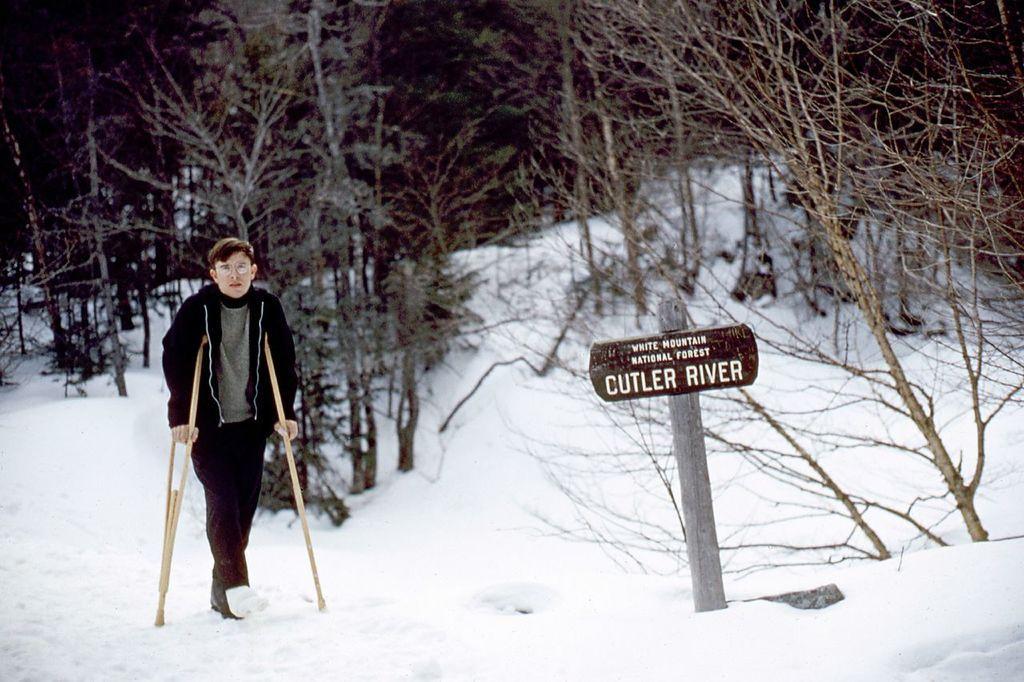Describe this image in one or two sentences. On the left side, we see a man in the black jacket is walking with the help of sticks. He is wearing the spectacles. At the bottom, we see the snow. In the middle, we see a wooden pole and a board in brown color with some text written on it. There are trees in the background. 